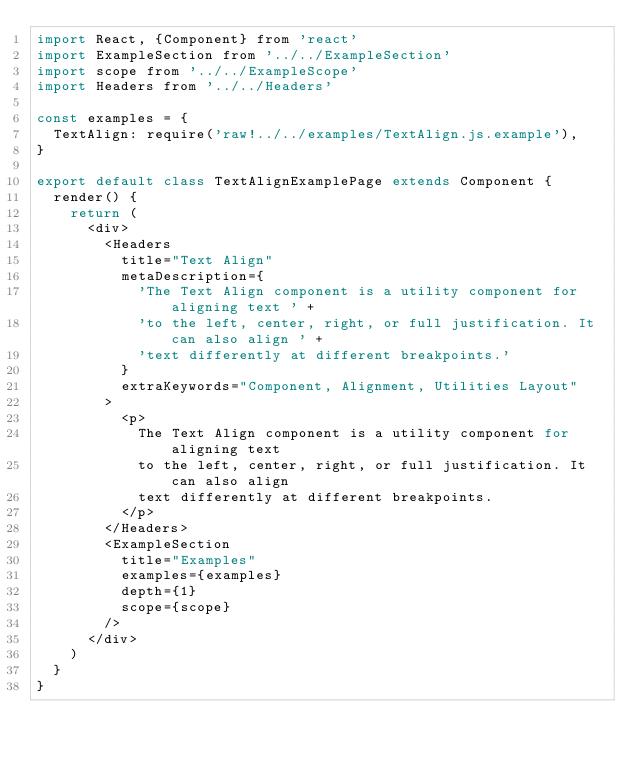<code> <loc_0><loc_0><loc_500><loc_500><_JavaScript_>import React, {Component} from 'react'
import ExampleSection from '../../ExampleSection'
import scope from '../../ExampleScope'
import Headers from '../../Headers'

const examples = {
  TextAlign: require('raw!../../examples/TextAlign.js.example'),
}

export default class TextAlignExamplePage extends Component {
  render() {
    return (
      <div>
        <Headers
          title="Text Align"
          metaDescription={
            'The Text Align component is a utility component for aligning text ' +
            'to the left, center, right, or full justification. It can also align ' +
            'text differently at different breakpoints.'
          }
          extraKeywords="Component, Alignment, Utilities Layout"
        >
          <p>
            The Text Align component is a utility component for aligning text
            to the left, center, right, or full justification. It can also align
            text differently at different breakpoints.
          </p>
        </Headers>
        <ExampleSection
          title="Examples"
          examples={examples}
          depth={1}
          scope={scope}
        />
      </div>
    )
  }
}
</code> 